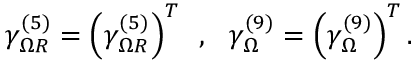<formula> <loc_0><loc_0><loc_500><loc_500>\gamma _ { \Omega R } ^ { ( 5 ) } = \left ( \gamma _ { \Omega R } ^ { ( 5 ) } \right ) ^ { T } \, , \, \ \gamma _ { \Omega } ^ { ( 9 ) } = \left ( \gamma _ { \Omega } ^ { ( 9 ) } \right ) ^ { T } .</formula> 